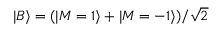Convert formula to latex. <formula><loc_0><loc_0><loc_500><loc_500>| B \rangle = ( | M = 1 \rangle + | M = - 1 \rangle ) / \sqrt { 2 }</formula> 